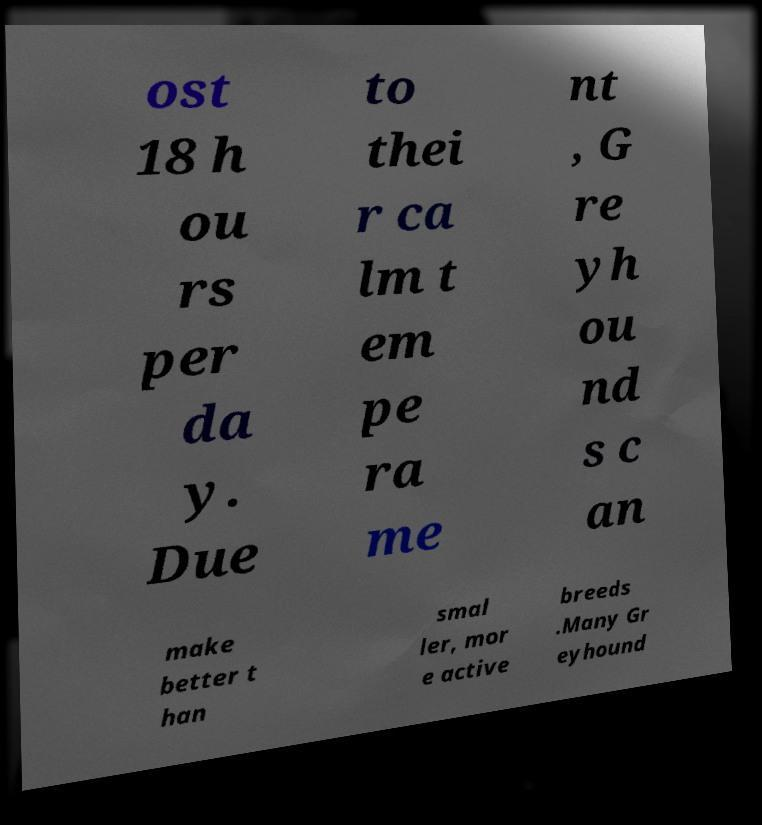For documentation purposes, I need the text within this image transcribed. Could you provide that? ost 18 h ou rs per da y. Due to thei r ca lm t em pe ra me nt , G re yh ou nd s c an make better t han smal ler, mor e active breeds .Many Gr eyhound 